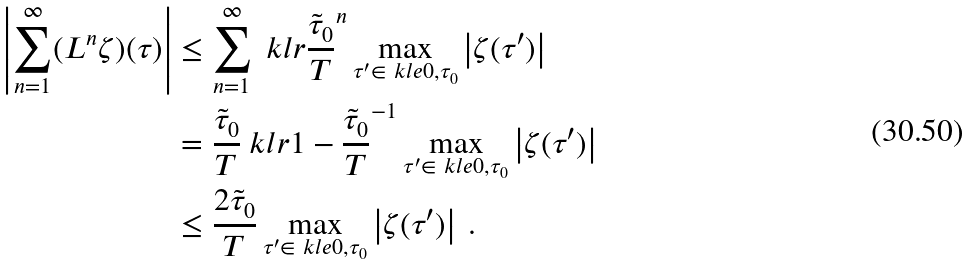<formula> <loc_0><loc_0><loc_500><loc_500>\left | \sum ^ { \infty } _ { n = 1 } ( L ^ { n } \zeta ) ( \tau ) \right | & \leq \sum ^ { \infty } _ { n = 1 } \ k l r { \frac { \tilde { \tau } _ { 0 } } { T } } ^ { n } \max _ { \tau ^ { \prime } \in \ k l e { 0 , \tau _ { 0 } } } \left | \zeta ( \tau ^ { \prime } ) \right | \\ & = \frac { \tilde { \tau } _ { 0 } } { T } \ k l r { 1 - \frac { \tilde { \tau } _ { 0 } } { T } } ^ { - 1 } \max _ { \tau ^ { \prime } \in \ k l e { 0 , \tau _ { 0 } } } \left | \zeta ( \tau ^ { \prime } ) \right | \\ & \leq \frac { 2 \tilde { \tau } _ { 0 } } { T } \max _ { \tau ^ { \prime } \in \ k l e { 0 , \tau _ { 0 } } } \left | \zeta ( \tau ^ { \prime } ) \right | \ .</formula> 